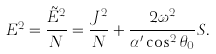Convert formula to latex. <formula><loc_0><loc_0><loc_500><loc_500>E ^ { 2 } = \frac { \tilde { E } ^ { 2 } } { N } = \frac { J ^ { 2 } } { N } + \frac { 2 \omega ^ { 2 } } { \alpha ^ { \prime } \cos ^ { 2 } \theta _ { 0 } } S .</formula> 